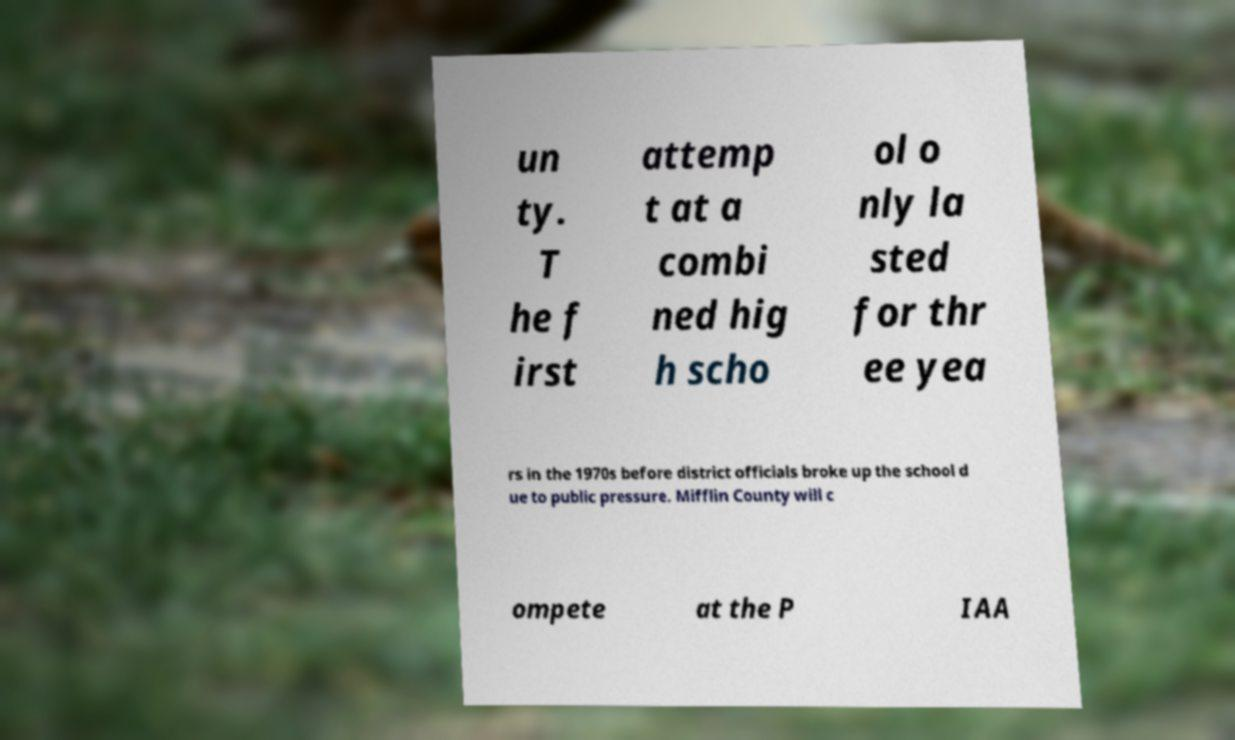Could you assist in decoding the text presented in this image and type it out clearly? un ty. T he f irst attemp t at a combi ned hig h scho ol o nly la sted for thr ee yea rs in the 1970s before district officials broke up the school d ue to public pressure. Mifflin County will c ompete at the P IAA 